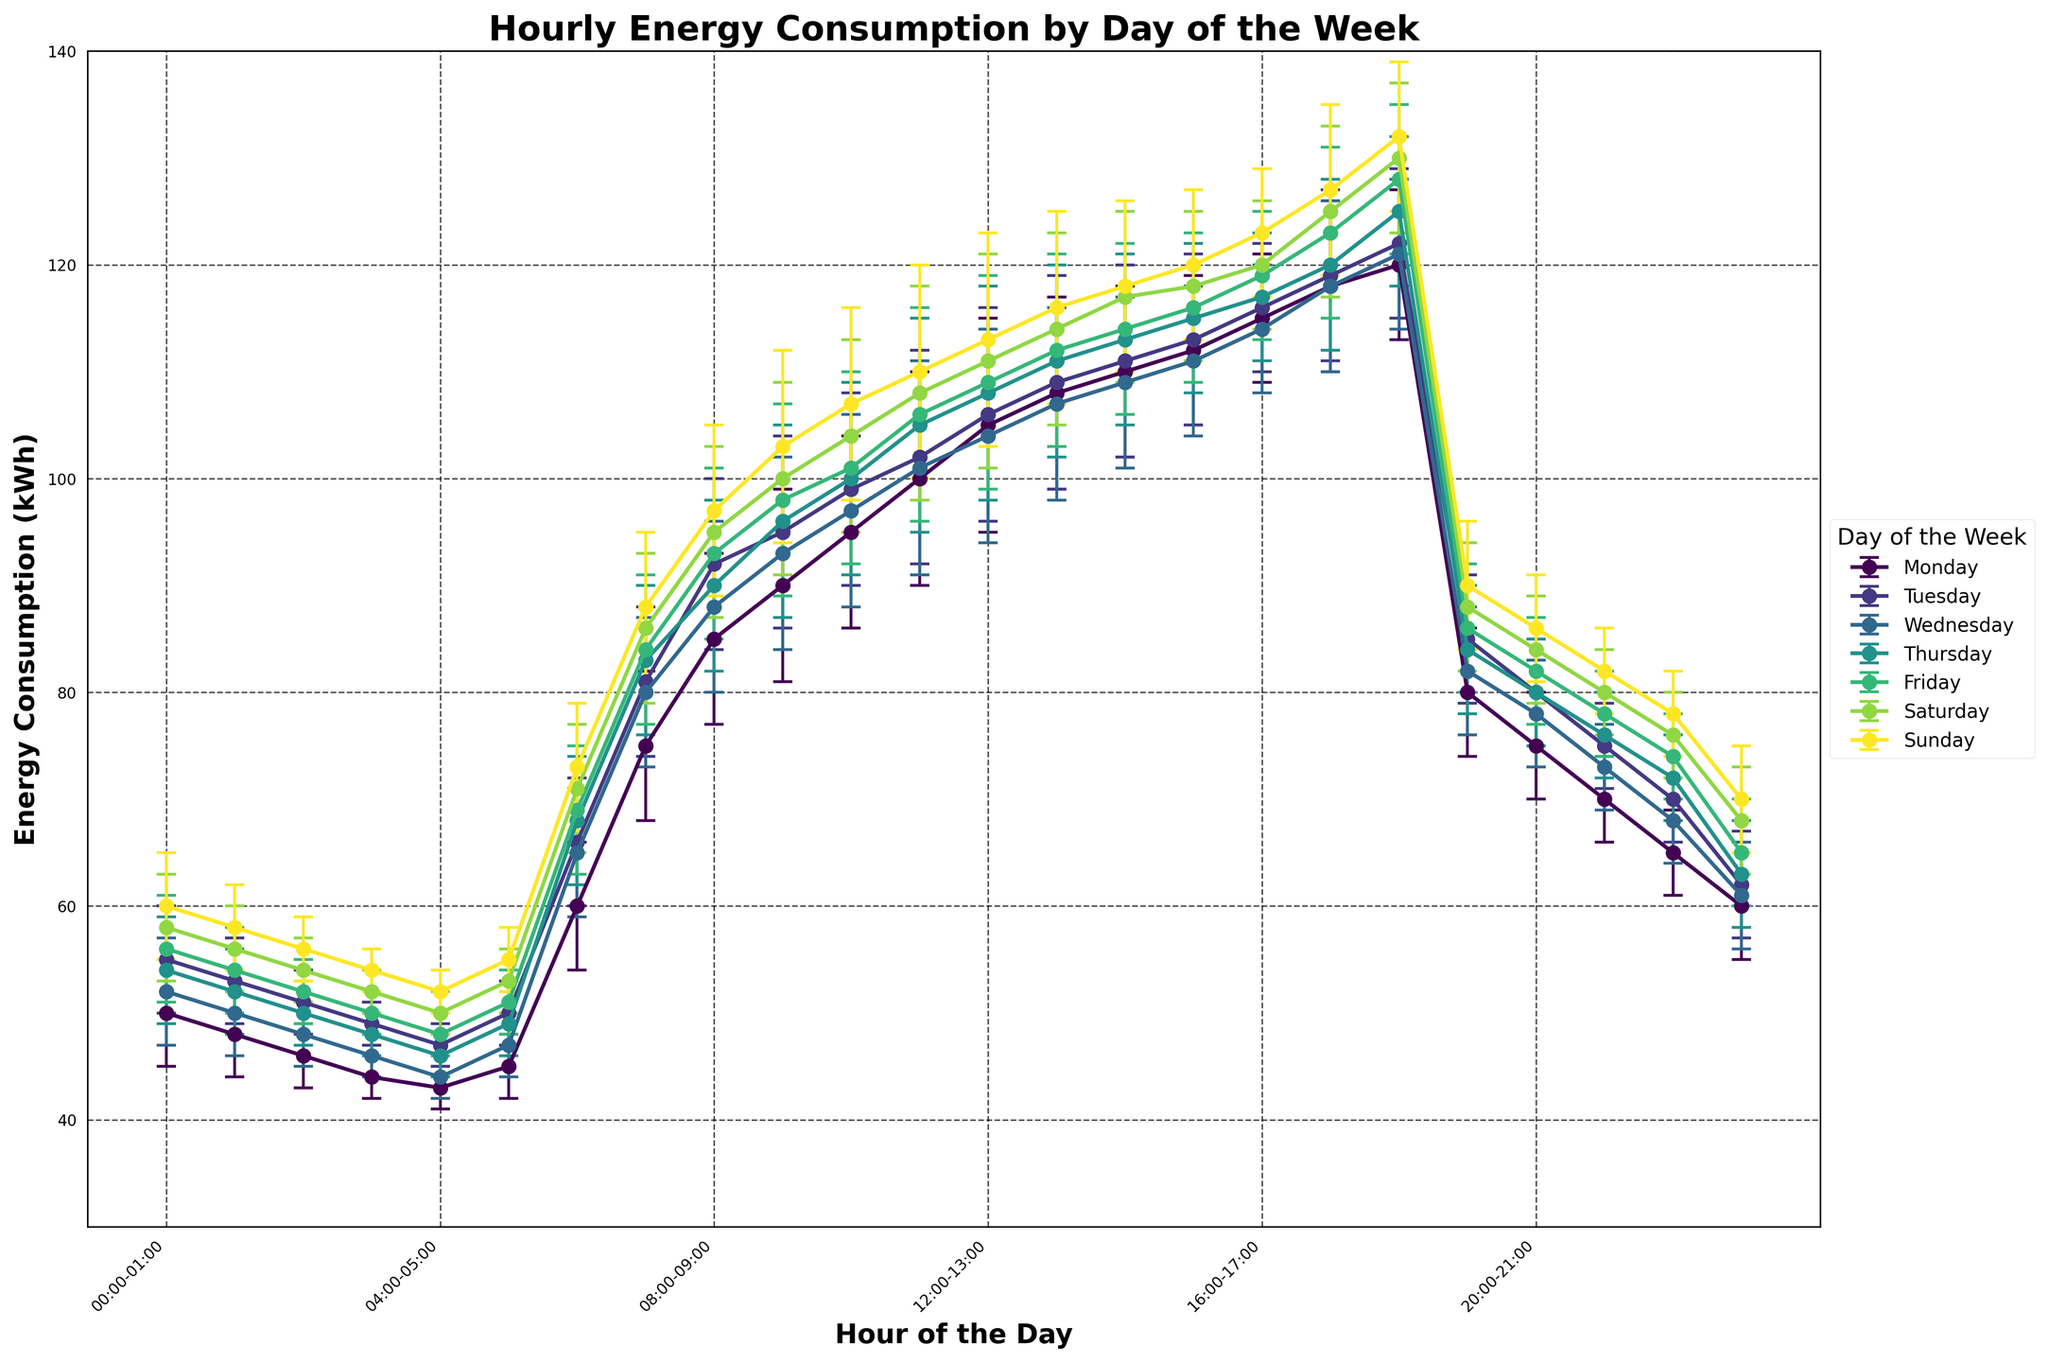What is the title of the figure? The title is usually the text on top of the figure indicating what the figure is about. In this case, the title can be seen at the top and reads 'Hourly Energy Consumption by Day of the Week'.
Answer: Hourly Energy Consumption by Day of the Week What are the labels on the x-axis and y-axis? The labels on the x-axis and y-axis describe what each axis represents. Here the x-axis represents 'Hour of the Day' and the y-axis represents 'Energy Consumption (kWh)'.
Answer: Hour of the Day; Energy Consumption (kWh) Which day of the week shows the highest energy consumption at 18:00-19:00? By checking the data points around 18:00-19:00 for each day, you will find that Sunday shows the highest energy consumption during this time.
Answer: Sunday What is the mean energy consumption during 08:00-09:00 on Monday? The mean energy consumption for each time slot is marked in the dataset. For Monday at 08:00-09:00, it is clearly shown as 85 kWh.
Answer: 85 kWh What day has the highest mean energy consumption at any given time, and what is that value? By inspecting the highest data points across all days and times, the highest mean energy consumption is on Sunday at 18:00-19:00, marked as 132 kWh.
Answer: Sunday, 132 kWh What is the range of error for the energy consumption measurement at 12:00-13:00 on Tuesday? To find this, look at the corresponding data point on Tuesday, 12:00-13:00. The error range is listed as 10 kWh.
Answer: 10 kWh How does the energy consumption at 11:00-12:00 on Wednesday compare to that of Friday? Comparison means checking the values for these exact times on the given days. On Wednesday, it is 101 kWh and on Friday, it is 106 kWh, so Friday's consumption is higher.
Answer: Friday's consumption is higher Which day has the smallest error range for energy consumption at 05:00-06:00? By examining the error ranges across all days at 05:00-06:00, it is 2 kWh for Monday, Tuesday, Wednesday, Thursday, and Friday. Therefore, all these days have the smallest error range for that time slot.
Answer: Monday, Tuesday, Wednesday, Thursday, Friday Between 17:00-18:00 and 18:00-19:00, which hourly slot on Saturday has the higher energy consumption? Comparing the data points for these specific hours on Saturday, 18:00-19:00 shows an energy consumption of 130 kWh while 17:00-18:00 shows 125 kWh. Therefore, 18:00-19:00 has the higher consumption.
Answer: 18:00-19:00 Looking at the typical pattern over the week, is there a specific time range when energy consumption peaks? Analyzing the data trends, it is clear that for all days, the peak energy consumption tends to occur between 12:00 and 19:00.
Answer: 12:00-19:00 